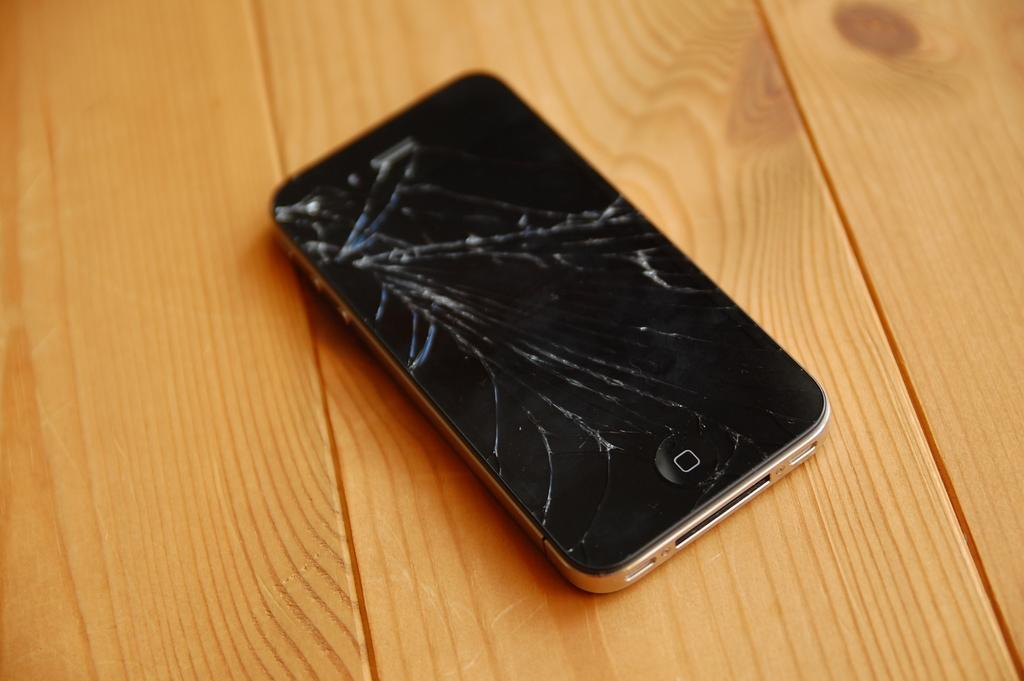<image>
Offer a succinct explanation of the picture presented. An iphone with a cracked screen sits on a wooden table with no readable text visable. 